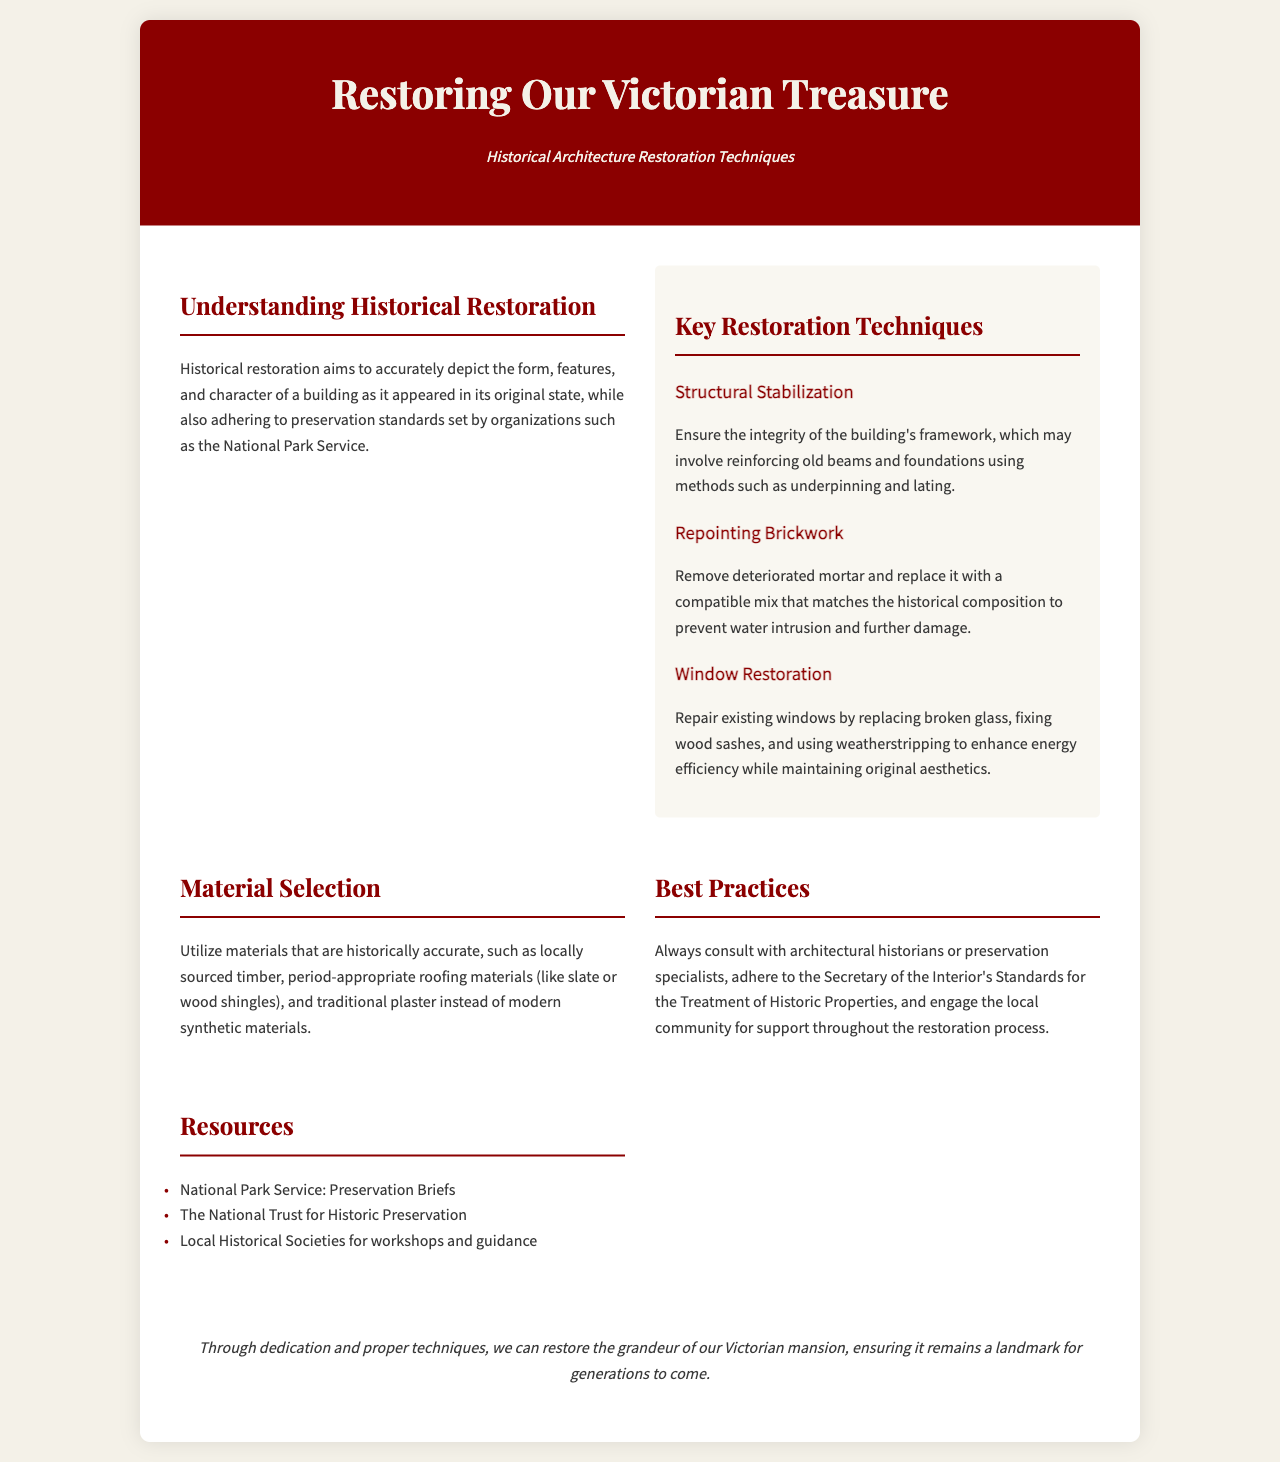What is the title of the brochure? The title is prominently displayed in the header section of the document.
Answer: Restoring Our Victorian Treasure What organization sets preservation standards mentioned in the document? This organization is referred to in the section discussing historical restoration.
Answer: National Park Service Name one key restoration technique listed. Key techniques are detailed in a specific section dedicated to them.
Answer: Structural Stabilization What is emphasized for material selection? The document highlights an important aspect of restoring materials in the material selection section.
Answer: Historically accurate How many restoration techniques are specifically mentioned? The number of techniques can be counted in the section labeled "Key Restoration Techniques."
Answer: Three Which type of specialists should always be consulted according to best practices? This information is found in the section discussing best practices for restoration.
Answer: Architectural historians What does the conclusion express about the restoration? The conclusion summarizes the overall sentiment regarding the restoration efforts.
Answer: Grandeur Name one resource listed in the brochure. The brochure provides several resources in the resources section.
Answer: National Trust for Historic Preservation 